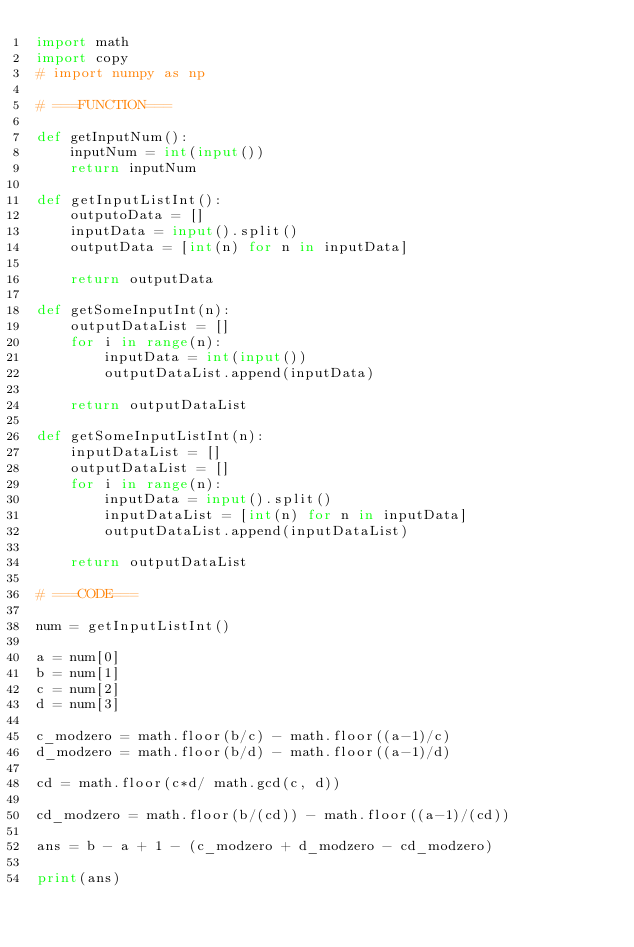<code> <loc_0><loc_0><loc_500><loc_500><_Python_>import math
import copy
# import numpy as np

# ===FUNCTION===

def getInputNum():
    inputNum = int(input())
    return inputNum

def getInputListInt():
    outputoData = []
    inputData = input().split()
    outputData = [int(n) for n in inputData]

    return outputData

def getSomeInputInt(n):
    outputDataList = []
    for i in range(n):
        inputData = int(input())
        outputDataList.append(inputData)

    return outputDataList

def getSomeInputListInt(n):
    inputDataList = []
    outputDataList = []
    for i in range(n):
        inputData = input().split()
        inputDataList = [int(n) for n in inputData]
        outputDataList.append(inputDataList)

    return outputDataList

# ===CODE===

num = getInputListInt()

a = num[0]
b = num[1]
c = num[2]
d = num[3]

c_modzero = math.floor(b/c) - math.floor((a-1)/c)
d_modzero = math.floor(b/d) - math.floor((a-1)/d)

cd = math.floor(c*d/ math.gcd(c, d))

cd_modzero = math.floor(b/(cd)) - math.floor((a-1)/(cd))

ans = b - a + 1 - (c_modzero + d_modzero - cd_modzero)

print(ans)</code> 